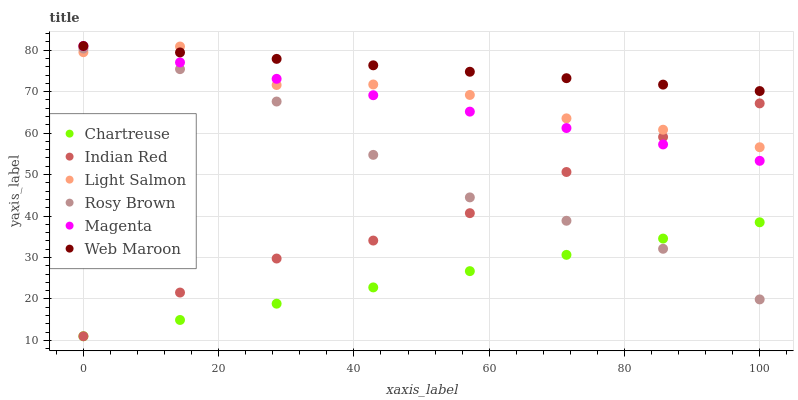Does Chartreuse have the minimum area under the curve?
Answer yes or no. Yes. Does Web Maroon have the maximum area under the curve?
Answer yes or no. Yes. Does Rosy Brown have the minimum area under the curve?
Answer yes or no. No. Does Rosy Brown have the maximum area under the curve?
Answer yes or no. No. Is Chartreuse the smoothest?
Answer yes or no. Yes. Is Light Salmon the roughest?
Answer yes or no. Yes. Is Rosy Brown the smoothest?
Answer yes or no. No. Is Rosy Brown the roughest?
Answer yes or no. No. Does Chartreuse have the lowest value?
Answer yes or no. Yes. Does Rosy Brown have the lowest value?
Answer yes or no. No. Does Magenta have the highest value?
Answer yes or no. Yes. Does Rosy Brown have the highest value?
Answer yes or no. No. Is Rosy Brown less than Magenta?
Answer yes or no. Yes. Is Web Maroon greater than Rosy Brown?
Answer yes or no. Yes. Does Chartreuse intersect Rosy Brown?
Answer yes or no. Yes. Is Chartreuse less than Rosy Brown?
Answer yes or no. No. Is Chartreuse greater than Rosy Brown?
Answer yes or no. No. Does Rosy Brown intersect Magenta?
Answer yes or no. No. 